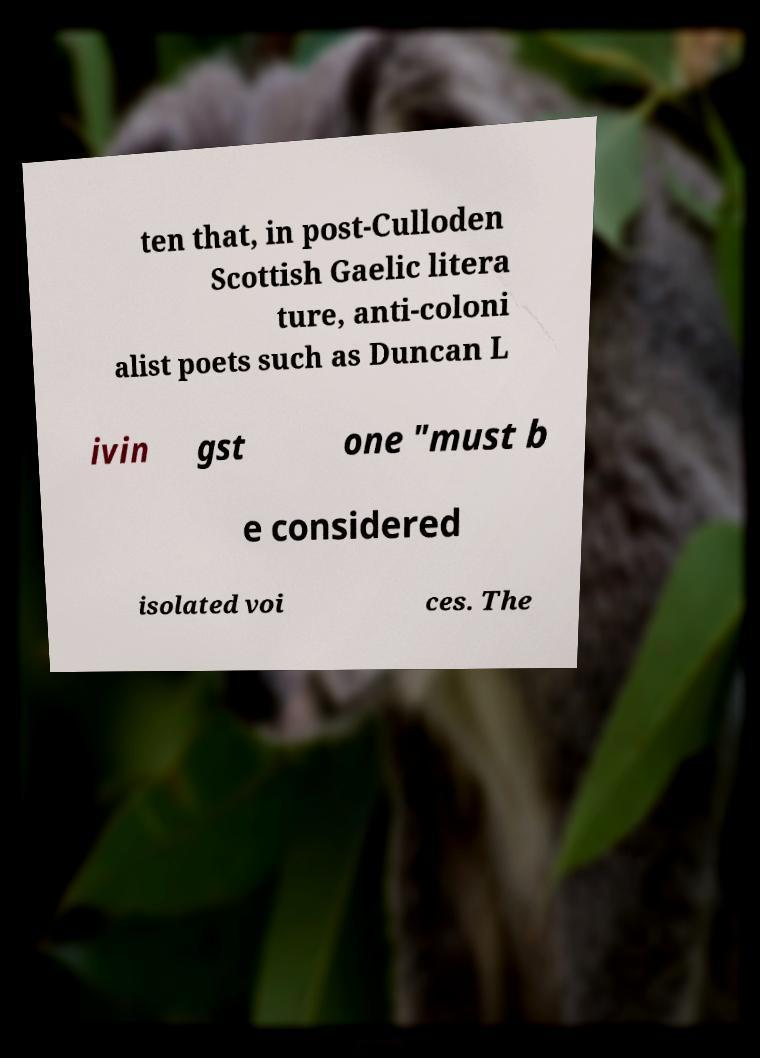Please read and relay the text visible in this image. What does it say? ten that, in post-Culloden Scottish Gaelic litera ture, anti-coloni alist poets such as Duncan L ivin gst one "must b e considered isolated voi ces. The 